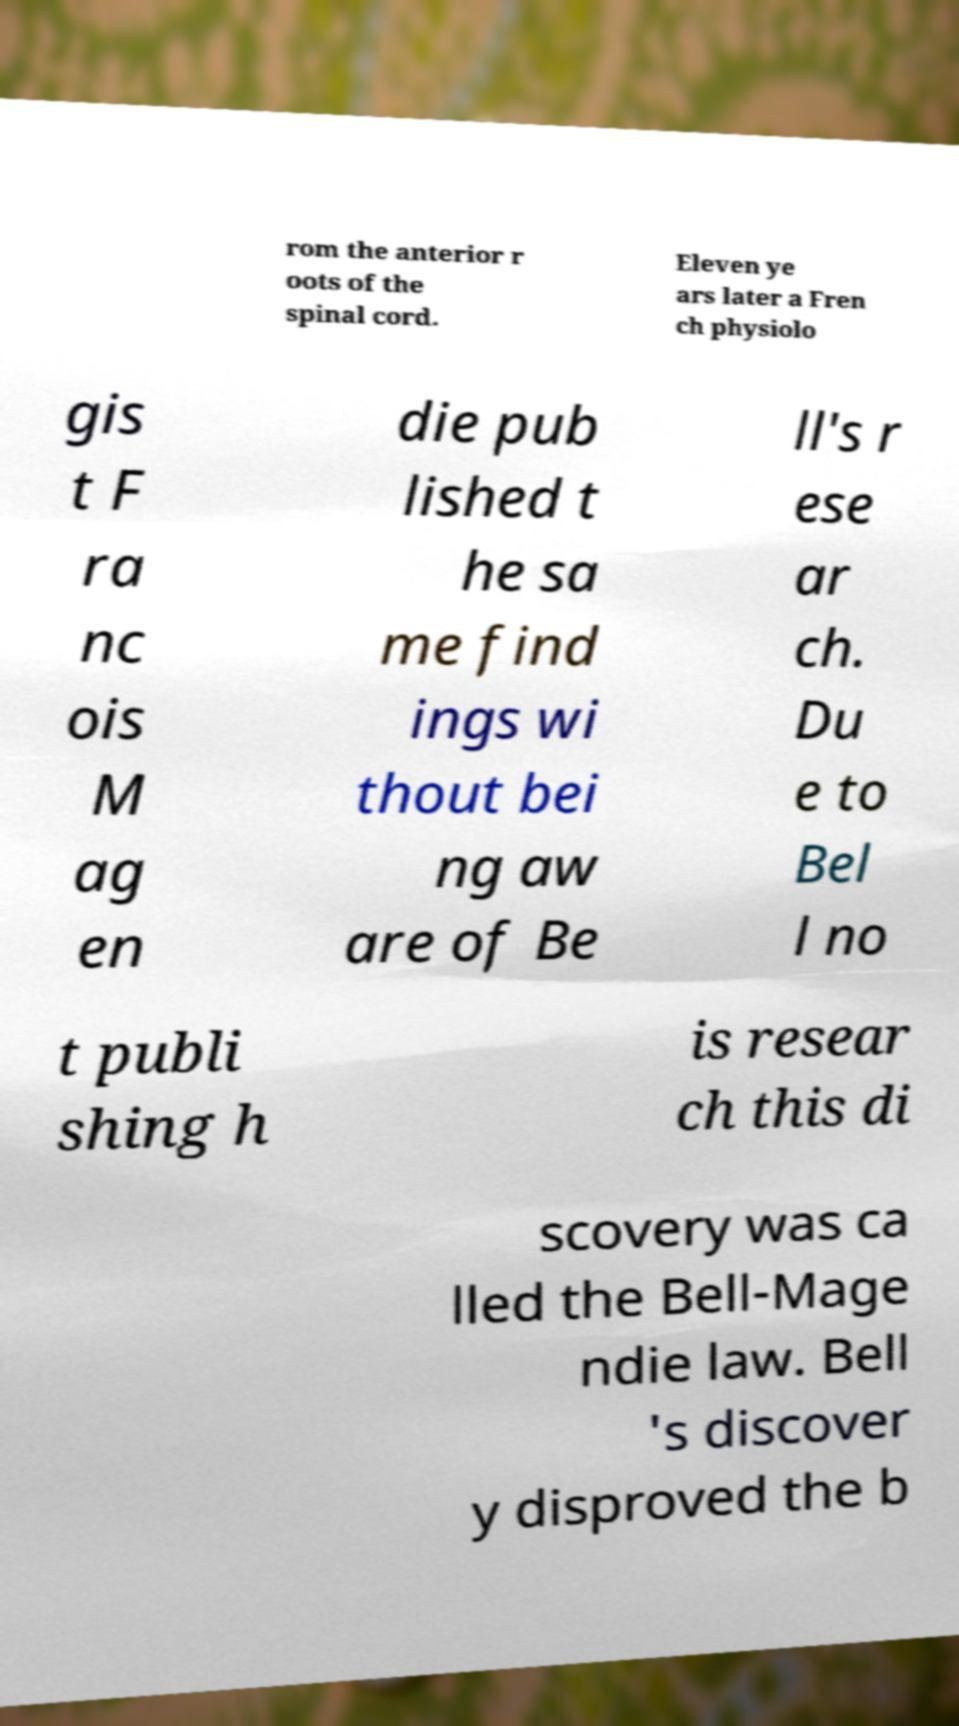For documentation purposes, I need the text within this image transcribed. Could you provide that? rom the anterior r oots of the spinal cord. Eleven ye ars later a Fren ch physiolo gis t F ra nc ois M ag en die pub lished t he sa me find ings wi thout bei ng aw are of Be ll's r ese ar ch. Du e to Bel l no t publi shing h is resear ch this di scovery was ca lled the Bell-Mage ndie law. Bell 's discover y disproved the b 